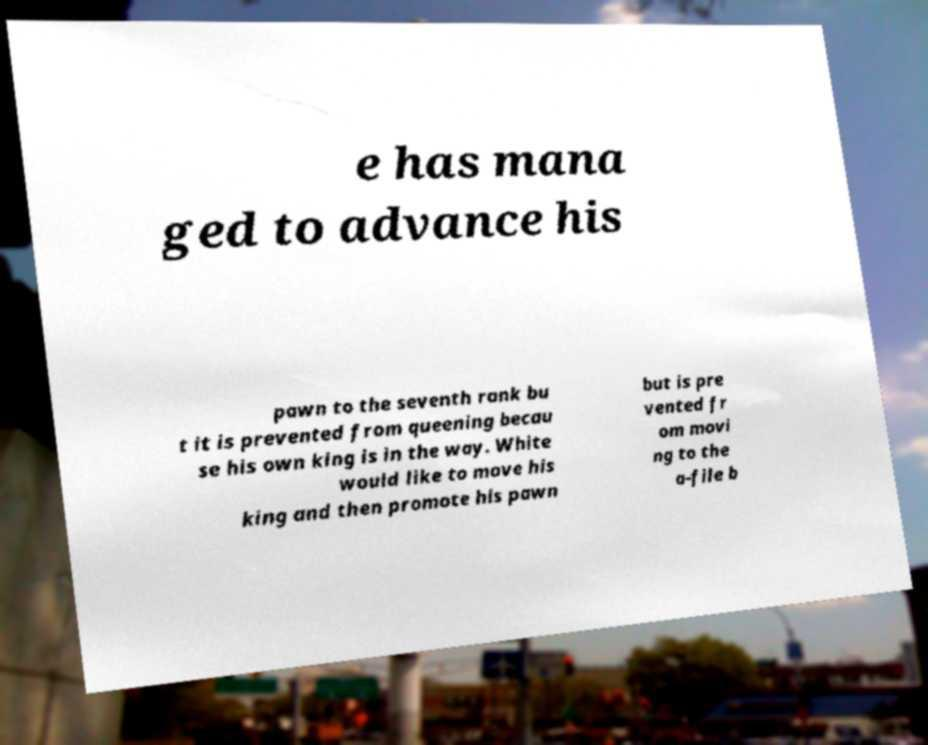Can you accurately transcribe the text from the provided image for me? e has mana ged to advance his pawn to the seventh rank bu t it is prevented from queening becau se his own king is in the way. White would like to move his king and then promote his pawn but is pre vented fr om movi ng to the a-file b 